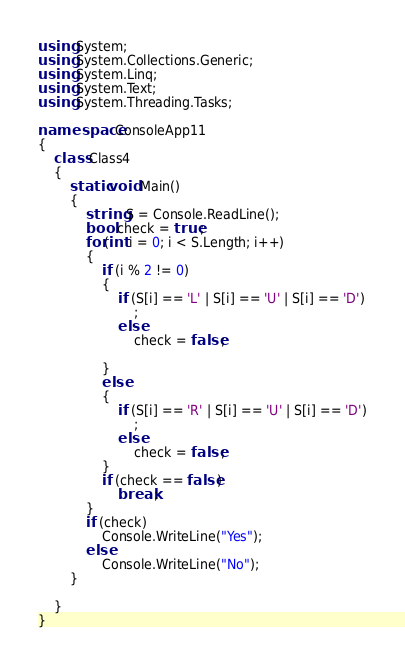<code> <loc_0><loc_0><loc_500><loc_500><_C#_>using System;
using System.Collections.Generic;
using System.Linq;
using System.Text;
using System.Threading.Tasks;

namespace ConsoleApp11
{
    class Class4
    {
        static void Main()
        {
            string S = Console.ReadLine();
            bool check = true;
            for(int i = 0; i < S.Length; i++)
            {
                if (i % 2 != 0)
                {
                    if (S[i] == 'L' | S[i] == 'U' | S[i] == 'D')
                        ;
                    else
                        check = false;

                }
                else
                {
                    if (S[i] == 'R' | S[i] == 'U' | S[i] == 'D')
                        ;
                    else
                        check = false;
                }
                if (check == false)
                    break;
            }
            if (check)
                Console.WriteLine("Yes");
            else
                Console.WriteLine("No");
        }
        
    }
}</code> 